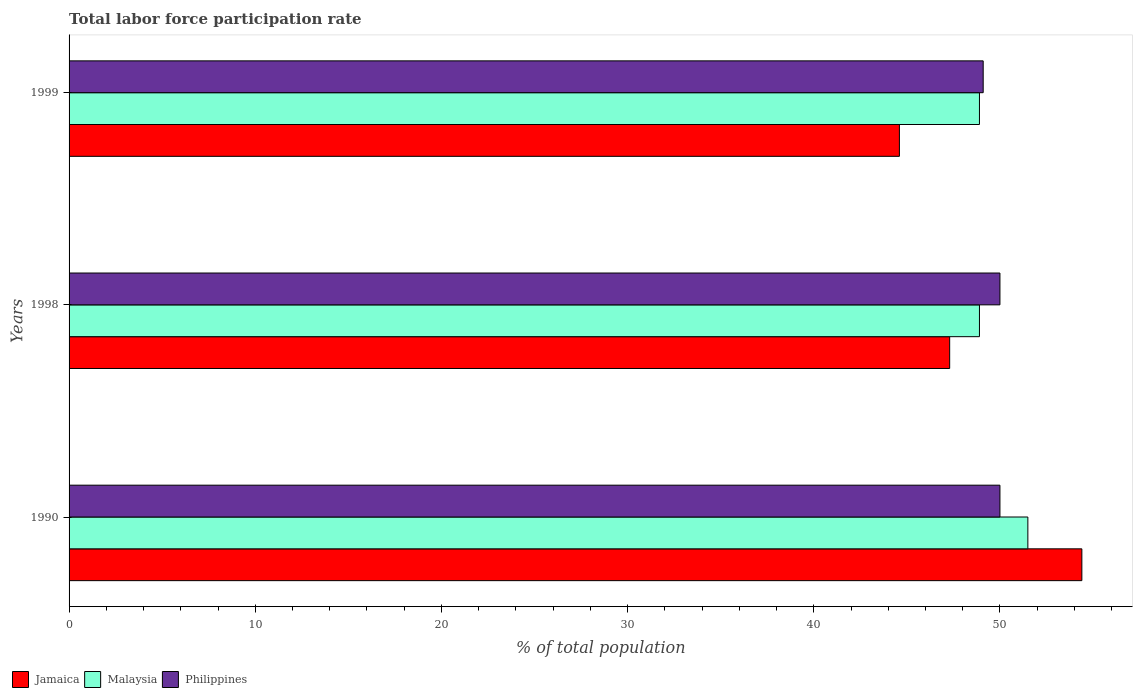Are the number of bars per tick equal to the number of legend labels?
Your answer should be very brief. Yes. In how many cases, is the number of bars for a given year not equal to the number of legend labels?
Provide a short and direct response. 0. What is the total labor force participation rate in Jamaica in 1990?
Provide a short and direct response. 54.4. Across all years, what is the minimum total labor force participation rate in Malaysia?
Offer a very short reply. 48.9. In which year was the total labor force participation rate in Philippines maximum?
Make the answer very short. 1990. What is the total total labor force participation rate in Jamaica in the graph?
Make the answer very short. 146.3. What is the difference between the total labor force participation rate in Malaysia in 1990 and that in 1998?
Your answer should be very brief. 2.6. What is the difference between the total labor force participation rate in Philippines in 1990 and the total labor force participation rate in Jamaica in 1999?
Offer a terse response. 5.4. What is the average total labor force participation rate in Philippines per year?
Offer a terse response. 49.7. In the year 1998, what is the difference between the total labor force participation rate in Malaysia and total labor force participation rate in Philippines?
Offer a very short reply. -1.1. In how many years, is the total labor force participation rate in Malaysia greater than 48 %?
Ensure brevity in your answer.  3. What is the ratio of the total labor force participation rate in Malaysia in 1990 to that in 1998?
Give a very brief answer. 1.05. Is the difference between the total labor force participation rate in Malaysia in 1990 and 1999 greater than the difference between the total labor force participation rate in Philippines in 1990 and 1999?
Your response must be concise. Yes. What is the difference between the highest and the second highest total labor force participation rate in Jamaica?
Provide a short and direct response. 7.1. What is the difference between the highest and the lowest total labor force participation rate in Philippines?
Offer a terse response. 0.9. Is the sum of the total labor force participation rate in Philippines in 1990 and 1999 greater than the maximum total labor force participation rate in Malaysia across all years?
Your response must be concise. Yes. What does the 3rd bar from the top in 1990 represents?
Offer a terse response. Jamaica. What does the 2nd bar from the bottom in 1998 represents?
Your answer should be compact. Malaysia. Is it the case that in every year, the sum of the total labor force participation rate in Malaysia and total labor force participation rate in Philippines is greater than the total labor force participation rate in Jamaica?
Your response must be concise. Yes. How many bars are there?
Provide a succinct answer. 9. How many years are there in the graph?
Offer a very short reply. 3. Are the values on the major ticks of X-axis written in scientific E-notation?
Give a very brief answer. No. How many legend labels are there?
Keep it short and to the point. 3. How are the legend labels stacked?
Ensure brevity in your answer.  Horizontal. What is the title of the graph?
Provide a short and direct response. Total labor force participation rate. What is the label or title of the X-axis?
Offer a very short reply. % of total population. What is the label or title of the Y-axis?
Give a very brief answer. Years. What is the % of total population of Jamaica in 1990?
Keep it short and to the point. 54.4. What is the % of total population in Malaysia in 1990?
Give a very brief answer. 51.5. What is the % of total population of Jamaica in 1998?
Ensure brevity in your answer.  47.3. What is the % of total population in Malaysia in 1998?
Offer a terse response. 48.9. What is the % of total population of Philippines in 1998?
Your answer should be compact. 50. What is the % of total population of Jamaica in 1999?
Provide a succinct answer. 44.6. What is the % of total population of Malaysia in 1999?
Your answer should be compact. 48.9. What is the % of total population in Philippines in 1999?
Offer a terse response. 49.1. Across all years, what is the maximum % of total population in Jamaica?
Ensure brevity in your answer.  54.4. Across all years, what is the maximum % of total population of Malaysia?
Give a very brief answer. 51.5. Across all years, what is the minimum % of total population in Jamaica?
Offer a very short reply. 44.6. Across all years, what is the minimum % of total population in Malaysia?
Provide a short and direct response. 48.9. Across all years, what is the minimum % of total population of Philippines?
Offer a terse response. 49.1. What is the total % of total population in Jamaica in the graph?
Your answer should be compact. 146.3. What is the total % of total population in Malaysia in the graph?
Make the answer very short. 149.3. What is the total % of total population in Philippines in the graph?
Make the answer very short. 149.1. What is the difference between the % of total population in Malaysia in 1990 and that in 1998?
Give a very brief answer. 2.6. What is the difference between the % of total population in Philippines in 1990 and that in 1998?
Your response must be concise. 0. What is the difference between the % of total population in Malaysia in 1990 and that in 1999?
Make the answer very short. 2.6. What is the difference between the % of total population of Jamaica in 1998 and that in 1999?
Provide a short and direct response. 2.7. What is the difference between the % of total population of Malaysia in 1998 and that in 1999?
Give a very brief answer. 0. What is the difference between the % of total population of Jamaica in 1990 and the % of total population of Philippines in 1998?
Offer a terse response. 4.4. What is the difference between the % of total population of Malaysia in 1990 and the % of total population of Philippines in 1998?
Make the answer very short. 1.5. What is the difference between the % of total population of Jamaica in 1990 and the % of total population of Malaysia in 1999?
Ensure brevity in your answer.  5.5. What is the difference between the % of total population in Jamaica in 1990 and the % of total population in Philippines in 1999?
Offer a terse response. 5.3. What is the difference between the % of total population of Jamaica in 1998 and the % of total population of Philippines in 1999?
Keep it short and to the point. -1.8. What is the difference between the % of total population in Malaysia in 1998 and the % of total population in Philippines in 1999?
Ensure brevity in your answer.  -0.2. What is the average % of total population of Jamaica per year?
Give a very brief answer. 48.77. What is the average % of total population of Malaysia per year?
Make the answer very short. 49.77. What is the average % of total population in Philippines per year?
Offer a very short reply. 49.7. In the year 1990, what is the difference between the % of total population in Jamaica and % of total population in Philippines?
Your answer should be compact. 4.4. In the year 1990, what is the difference between the % of total population of Malaysia and % of total population of Philippines?
Your response must be concise. 1.5. In the year 1998, what is the difference between the % of total population of Jamaica and % of total population of Malaysia?
Offer a terse response. -1.6. In the year 1998, what is the difference between the % of total population of Malaysia and % of total population of Philippines?
Your answer should be compact. -1.1. In the year 1999, what is the difference between the % of total population in Jamaica and % of total population in Malaysia?
Ensure brevity in your answer.  -4.3. In the year 1999, what is the difference between the % of total population in Jamaica and % of total population in Philippines?
Your answer should be very brief. -4.5. What is the ratio of the % of total population of Jamaica in 1990 to that in 1998?
Your answer should be compact. 1.15. What is the ratio of the % of total population in Malaysia in 1990 to that in 1998?
Your answer should be compact. 1.05. What is the ratio of the % of total population of Philippines in 1990 to that in 1998?
Keep it short and to the point. 1. What is the ratio of the % of total population in Jamaica in 1990 to that in 1999?
Make the answer very short. 1.22. What is the ratio of the % of total population of Malaysia in 1990 to that in 1999?
Your response must be concise. 1.05. What is the ratio of the % of total population in Philippines in 1990 to that in 1999?
Offer a very short reply. 1.02. What is the ratio of the % of total population of Jamaica in 1998 to that in 1999?
Your answer should be very brief. 1.06. What is the ratio of the % of total population in Malaysia in 1998 to that in 1999?
Your answer should be compact. 1. What is the ratio of the % of total population of Philippines in 1998 to that in 1999?
Your answer should be very brief. 1.02. What is the difference between the highest and the lowest % of total population in Malaysia?
Your response must be concise. 2.6. 